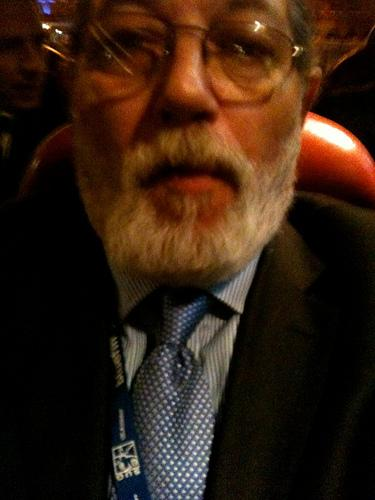The person wearing the blue tie looks most like whom?

Choices:
A) idris elba
B) liv morgan
C) donald pleasence
D) keith david donald pleasence 